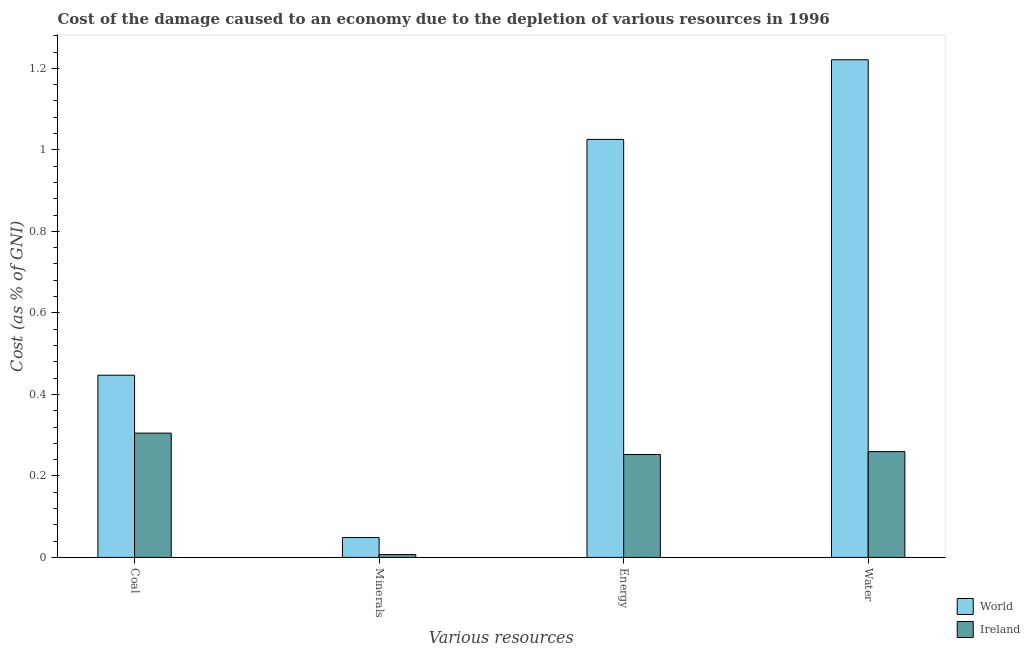Are the number of bars on each tick of the X-axis equal?
Your answer should be compact. Yes. What is the label of the 2nd group of bars from the left?
Offer a terse response. Minerals. What is the cost of damage due to depletion of coal in Ireland?
Ensure brevity in your answer.  0.31. Across all countries, what is the maximum cost of damage due to depletion of water?
Give a very brief answer. 1.22. Across all countries, what is the minimum cost of damage due to depletion of minerals?
Provide a succinct answer. 0.01. In which country was the cost of damage due to depletion of water maximum?
Your response must be concise. World. In which country was the cost of damage due to depletion of minerals minimum?
Offer a very short reply. Ireland. What is the total cost of damage due to depletion of energy in the graph?
Ensure brevity in your answer.  1.28. What is the difference between the cost of damage due to depletion of coal in Ireland and that in World?
Keep it short and to the point. -0.14. What is the difference between the cost of damage due to depletion of water in World and the cost of damage due to depletion of minerals in Ireland?
Ensure brevity in your answer.  1.21. What is the average cost of damage due to depletion of energy per country?
Ensure brevity in your answer.  0.64. What is the difference between the cost of damage due to depletion of coal and cost of damage due to depletion of energy in World?
Your response must be concise. -0.58. What is the ratio of the cost of damage due to depletion of coal in World to that in Ireland?
Keep it short and to the point. 1.47. What is the difference between the highest and the second highest cost of damage due to depletion of minerals?
Provide a short and direct response. 0.04. What is the difference between the highest and the lowest cost of damage due to depletion of coal?
Provide a succinct answer. 0.14. In how many countries, is the cost of damage due to depletion of minerals greater than the average cost of damage due to depletion of minerals taken over all countries?
Your response must be concise. 1. What does the 1st bar from the right in Water represents?
Provide a succinct answer. Ireland. Is it the case that in every country, the sum of the cost of damage due to depletion of coal and cost of damage due to depletion of minerals is greater than the cost of damage due to depletion of energy?
Your response must be concise. No. How many bars are there?
Keep it short and to the point. 8. Are all the bars in the graph horizontal?
Keep it short and to the point. No. Does the graph contain any zero values?
Your answer should be compact. No. How many legend labels are there?
Make the answer very short. 2. What is the title of the graph?
Offer a very short reply. Cost of the damage caused to an economy due to the depletion of various resources in 1996 . Does "Somalia" appear as one of the legend labels in the graph?
Offer a terse response. No. What is the label or title of the X-axis?
Your answer should be compact. Various resources. What is the label or title of the Y-axis?
Give a very brief answer. Cost (as % of GNI). What is the Cost (as % of GNI) of World in Coal?
Your response must be concise. 0.45. What is the Cost (as % of GNI) in Ireland in Coal?
Keep it short and to the point. 0.31. What is the Cost (as % of GNI) in World in Minerals?
Provide a short and direct response. 0.05. What is the Cost (as % of GNI) of Ireland in Minerals?
Your answer should be very brief. 0.01. What is the Cost (as % of GNI) in World in Energy?
Offer a very short reply. 1.03. What is the Cost (as % of GNI) of Ireland in Energy?
Give a very brief answer. 0.25. What is the Cost (as % of GNI) in World in Water?
Keep it short and to the point. 1.22. What is the Cost (as % of GNI) in Ireland in Water?
Provide a succinct answer. 0.26. Across all Various resources, what is the maximum Cost (as % of GNI) in World?
Make the answer very short. 1.22. Across all Various resources, what is the maximum Cost (as % of GNI) in Ireland?
Make the answer very short. 0.31. Across all Various resources, what is the minimum Cost (as % of GNI) of World?
Offer a very short reply. 0.05. Across all Various resources, what is the minimum Cost (as % of GNI) of Ireland?
Give a very brief answer. 0.01. What is the total Cost (as % of GNI) in World in the graph?
Your answer should be very brief. 2.74. What is the total Cost (as % of GNI) in Ireland in the graph?
Ensure brevity in your answer.  0.82. What is the difference between the Cost (as % of GNI) in World in Coal and that in Minerals?
Make the answer very short. 0.4. What is the difference between the Cost (as % of GNI) in Ireland in Coal and that in Minerals?
Give a very brief answer. 0.3. What is the difference between the Cost (as % of GNI) of World in Coal and that in Energy?
Give a very brief answer. -0.58. What is the difference between the Cost (as % of GNI) of Ireland in Coal and that in Energy?
Provide a short and direct response. 0.05. What is the difference between the Cost (as % of GNI) of World in Coal and that in Water?
Offer a terse response. -0.77. What is the difference between the Cost (as % of GNI) of Ireland in Coal and that in Water?
Offer a very short reply. 0.05. What is the difference between the Cost (as % of GNI) of World in Minerals and that in Energy?
Give a very brief answer. -0.98. What is the difference between the Cost (as % of GNI) in Ireland in Minerals and that in Energy?
Your answer should be compact. -0.25. What is the difference between the Cost (as % of GNI) of World in Minerals and that in Water?
Your answer should be compact. -1.17. What is the difference between the Cost (as % of GNI) in Ireland in Minerals and that in Water?
Ensure brevity in your answer.  -0.25. What is the difference between the Cost (as % of GNI) of World in Energy and that in Water?
Provide a succinct answer. -0.2. What is the difference between the Cost (as % of GNI) in Ireland in Energy and that in Water?
Ensure brevity in your answer.  -0.01. What is the difference between the Cost (as % of GNI) in World in Coal and the Cost (as % of GNI) in Ireland in Minerals?
Provide a short and direct response. 0.44. What is the difference between the Cost (as % of GNI) in World in Coal and the Cost (as % of GNI) in Ireland in Energy?
Your answer should be very brief. 0.19. What is the difference between the Cost (as % of GNI) in World in Coal and the Cost (as % of GNI) in Ireland in Water?
Make the answer very short. 0.19. What is the difference between the Cost (as % of GNI) of World in Minerals and the Cost (as % of GNI) of Ireland in Energy?
Ensure brevity in your answer.  -0.2. What is the difference between the Cost (as % of GNI) of World in Minerals and the Cost (as % of GNI) of Ireland in Water?
Make the answer very short. -0.21. What is the difference between the Cost (as % of GNI) of World in Energy and the Cost (as % of GNI) of Ireland in Water?
Offer a very short reply. 0.77. What is the average Cost (as % of GNI) in World per Various resources?
Your response must be concise. 0.69. What is the average Cost (as % of GNI) of Ireland per Various resources?
Offer a very short reply. 0.21. What is the difference between the Cost (as % of GNI) in World and Cost (as % of GNI) in Ireland in Coal?
Offer a very short reply. 0.14. What is the difference between the Cost (as % of GNI) in World and Cost (as % of GNI) in Ireland in Minerals?
Ensure brevity in your answer.  0.04. What is the difference between the Cost (as % of GNI) in World and Cost (as % of GNI) in Ireland in Energy?
Your answer should be compact. 0.77. What is the difference between the Cost (as % of GNI) of World and Cost (as % of GNI) of Ireland in Water?
Your answer should be very brief. 0.96. What is the ratio of the Cost (as % of GNI) in World in Coal to that in Minerals?
Provide a succinct answer. 9.16. What is the ratio of the Cost (as % of GNI) in Ireland in Coal to that in Minerals?
Your answer should be very brief. 43.55. What is the ratio of the Cost (as % of GNI) in World in Coal to that in Energy?
Provide a succinct answer. 0.44. What is the ratio of the Cost (as % of GNI) of Ireland in Coal to that in Energy?
Give a very brief answer. 1.21. What is the ratio of the Cost (as % of GNI) of World in Coal to that in Water?
Keep it short and to the point. 0.37. What is the ratio of the Cost (as % of GNI) of Ireland in Coal to that in Water?
Provide a succinct answer. 1.17. What is the ratio of the Cost (as % of GNI) of World in Minerals to that in Energy?
Provide a succinct answer. 0.05. What is the ratio of the Cost (as % of GNI) in Ireland in Minerals to that in Energy?
Give a very brief answer. 0.03. What is the ratio of the Cost (as % of GNI) of World in Minerals to that in Water?
Your response must be concise. 0.04. What is the ratio of the Cost (as % of GNI) in Ireland in Minerals to that in Water?
Your answer should be very brief. 0.03. What is the ratio of the Cost (as % of GNI) in World in Energy to that in Water?
Offer a terse response. 0.84. What is the difference between the highest and the second highest Cost (as % of GNI) of World?
Provide a succinct answer. 0.2. What is the difference between the highest and the second highest Cost (as % of GNI) of Ireland?
Provide a succinct answer. 0.05. What is the difference between the highest and the lowest Cost (as % of GNI) of World?
Provide a short and direct response. 1.17. What is the difference between the highest and the lowest Cost (as % of GNI) of Ireland?
Your response must be concise. 0.3. 